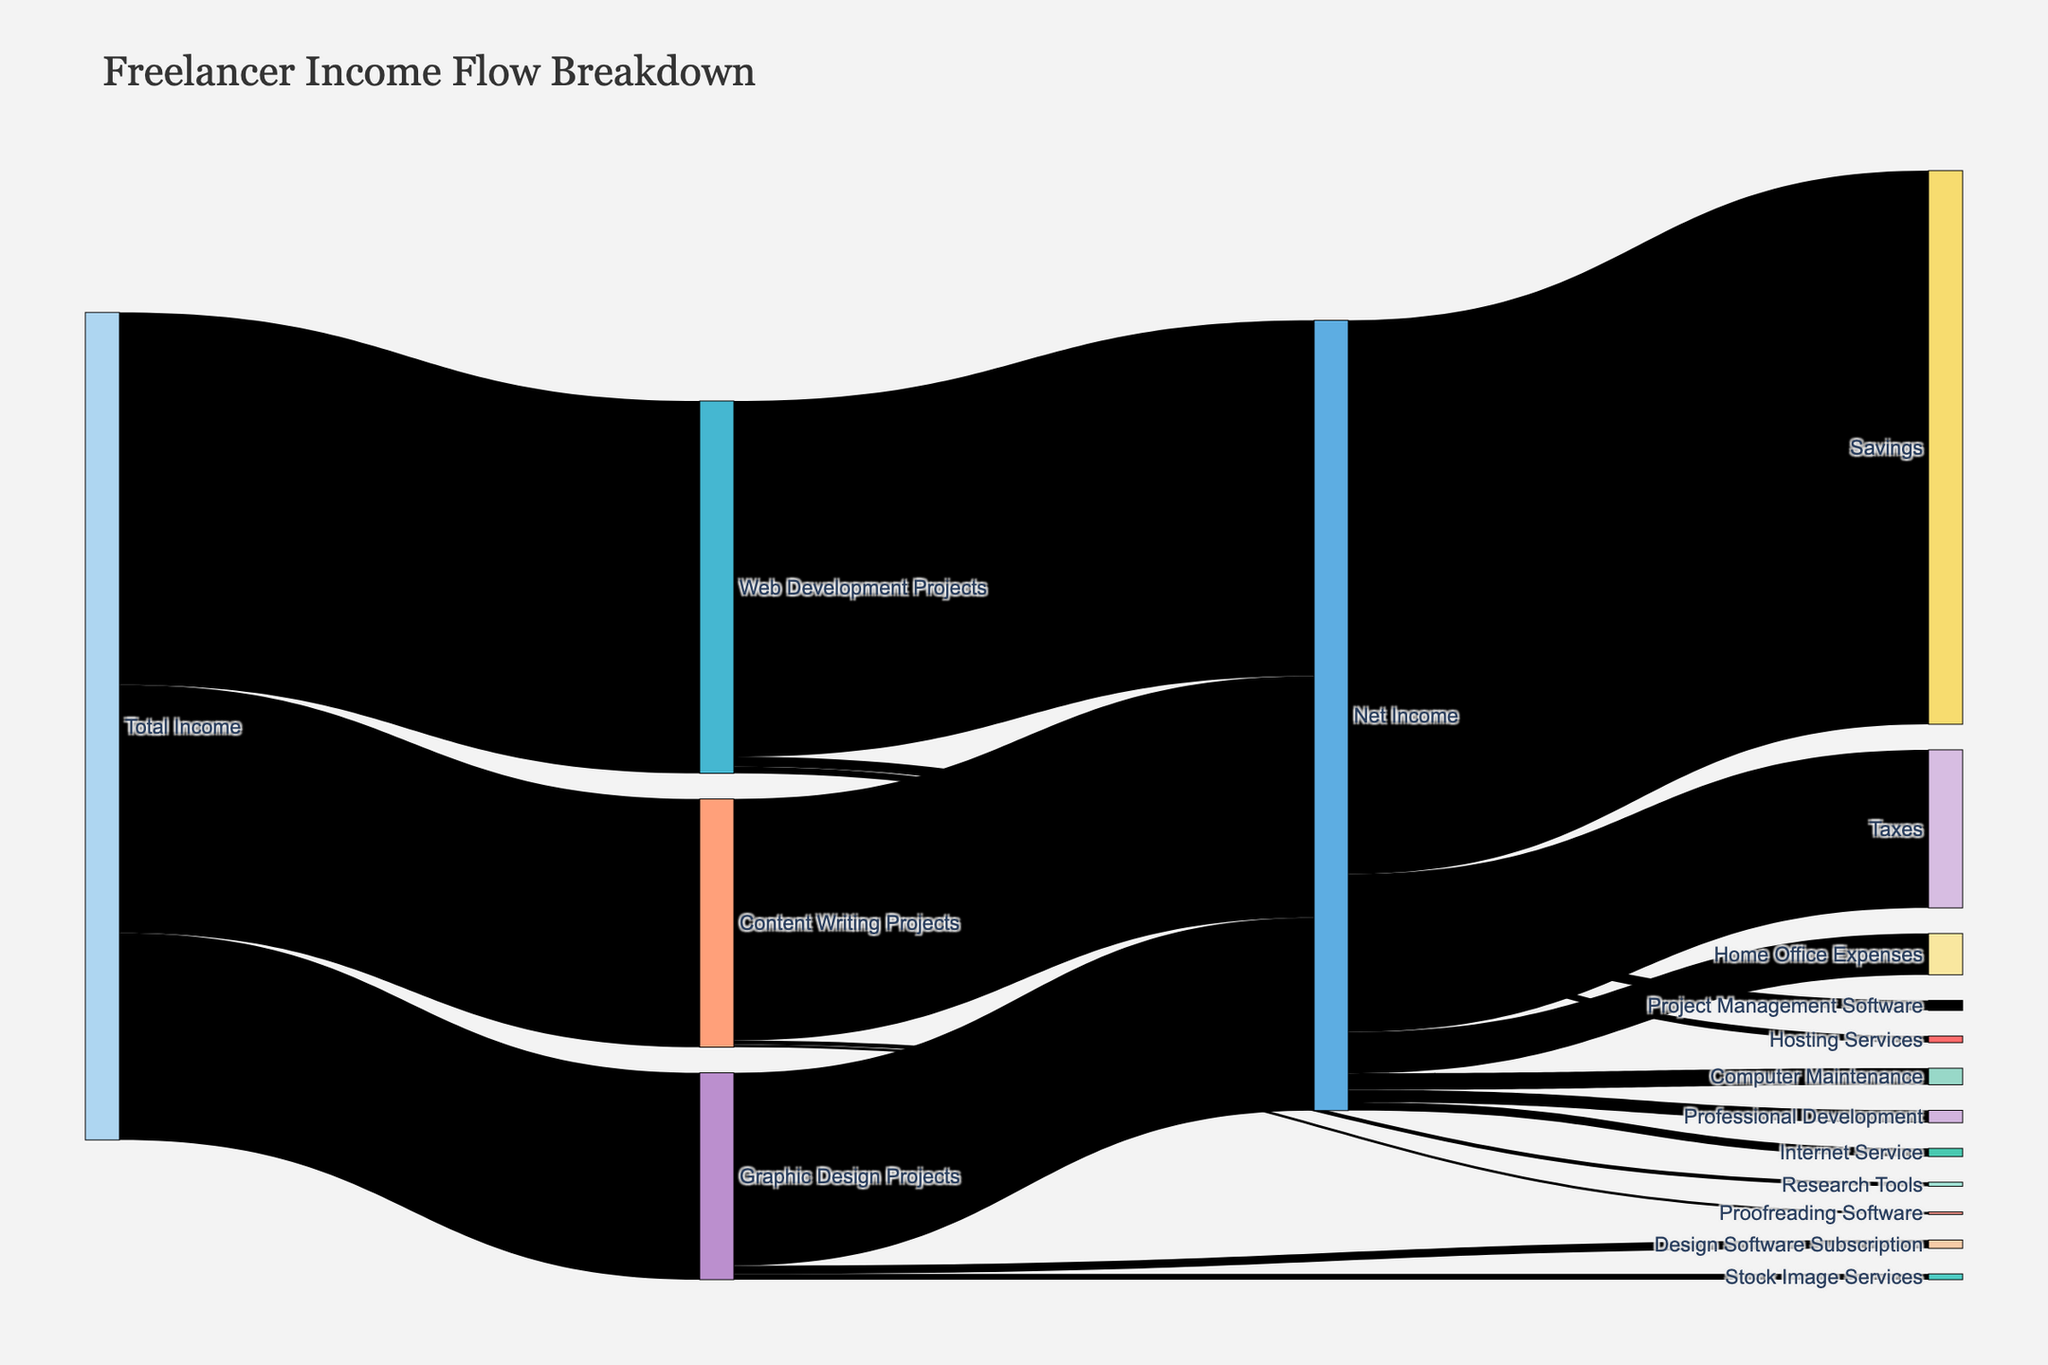What is the title of the Sankey diagram? Look at the top of the figure where the title is displayed.
Answer: Freelancer Income Flow Breakdown Which project type has the highest income? Compare the values flowing from 'Total Income' to the different project types. Web Development Projects receive $4500, Content Writing Projects $3000, and Graphic Design Projects $2500.
Answer: Web Development Projects What is the net income from Graphic Design Projects after expenses? Follow the flow from 'Graphic Design Projects' through the expenses and sum up the Net Income value, which is $2330.
Answer: $2330 How much is spent on Home Office Expenses? Locate the flow from 'Net Income' to 'Home Office Expenses' and read the value directly.
Answer: $500 Sum up all the expenses coming from 'Net Income'. Add the expenses from 'Net Income' to 'Taxes' ($1910), 'Home Office Expenses' ($500), 'Computer Maintenance' ($200), 'Internet Service' ($100), and 'Professional Development' ($150). 1910 + 500 + 200 + 100 + 150 = 2860.
Answer: $2860 Compare the total expenses for Web Development Projects with Content Writing Projects. Which one is higher? Sum up the expenses for both project types: Web Development Projects: $120 (Project Management Software) + $80 (Hosting Services) = $200. Content Writing Projects: $50 (Research Tools) + $30 (Proofreading Software) = $80.
Answer: Web Development Projects What is the total income before any expenses are deducted? Follow the flow from 'Total Income' and summarize the values directed to each project type. Total Income: $4500 (Web Development Projects) + $3000 (Content Writing Projects) + $2500 (Graphic Design Projects) = $10000.
Answer: $10000 Which expense category has the highest value? Compare the expense categories like 'Project Management Software', 'Hosting Services', 'Research Tools', 'Proofreading Software', 'Design Software Subscription', 'Stock Image Services', 'Taxes', 'Home Office Expenses', 'Computer Maintenance', 'Internet Service', and 'Professional Development'. 'Taxes' has the highest value of $1910.
Answer: Taxes How much is saved after all expenses are deducted? Follow the flow from 'Net Income' to 'Savings', which is $6690. This is the value after all deductions.
Answer: $6690 